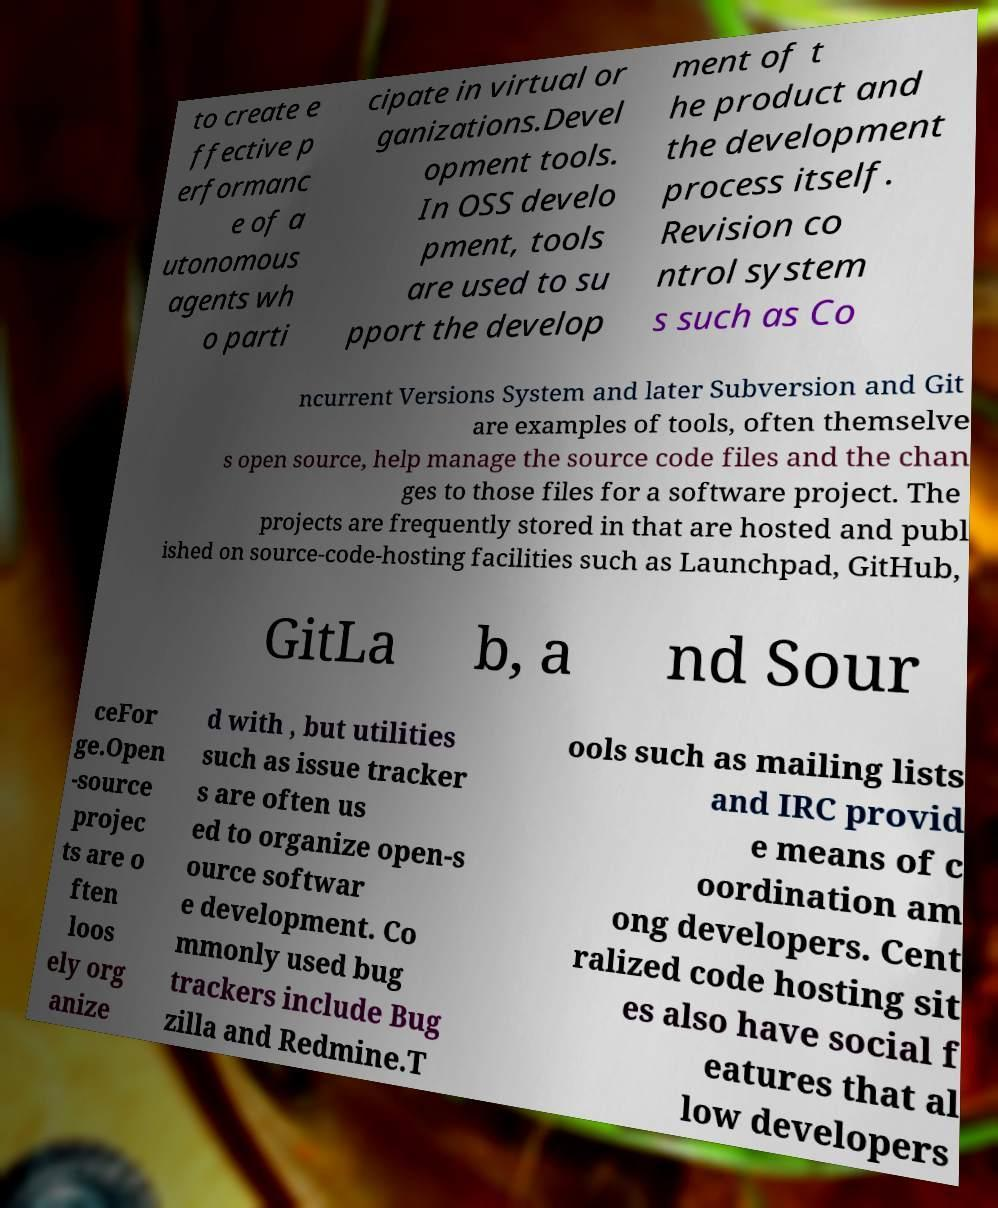Could you assist in decoding the text presented in this image and type it out clearly? to create e ffective p erformanc e of a utonomous agents wh o parti cipate in virtual or ganizations.Devel opment tools. In OSS develo pment, tools are used to su pport the develop ment of t he product and the development process itself. Revision co ntrol system s such as Co ncurrent Versions System and later Subversion and Git are examples of tools, often themselve s open source, help manage the source code files and the chan ges to those files for a software project. The projects are frequently stored in that are hosted and publ ished on source-code-hosting facilities such as Launchpad, GitHub, GitLa b, a nd Sour ceFor ge.Open -source projec ts are o ften loos ely org anize d with , but utilities such as issue tracker s are often us ed to organize open-s ource softwar e development. Co mmonly used bug trackers include Bug zilla and Redmine.T ools such as mailing lists and IRC provid e means of c oordination am ong developers. Cent ralized code hosting sit es also have social f eatures that al low developers 